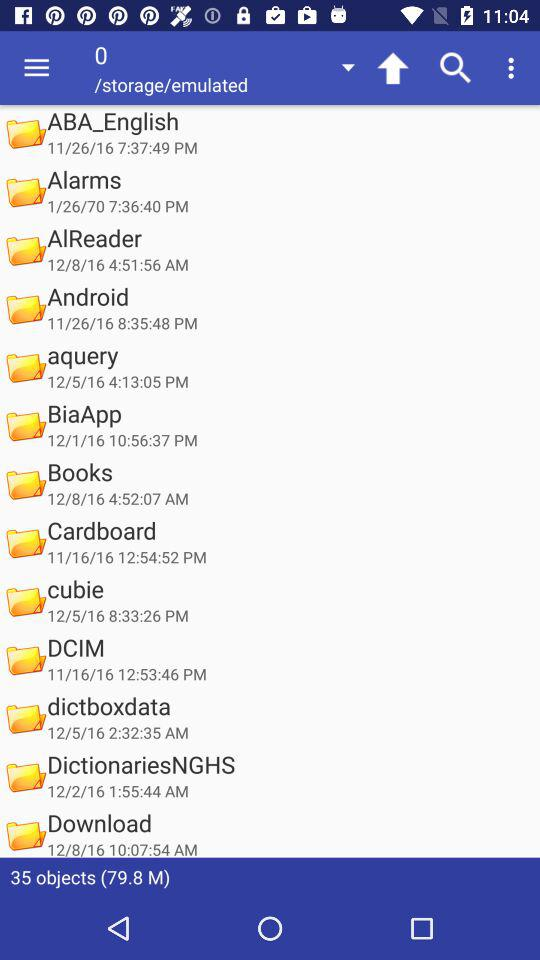What is the size of the objects? The size of the objects is 79.8 mb. 